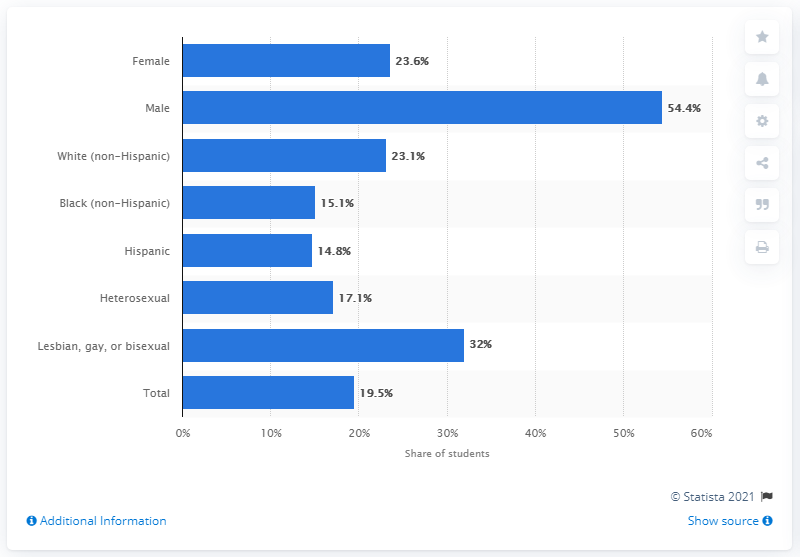Draw attention to some important aspects in this diagram. The male percentage is 54.4%. The ratio between females and males is 0.434... 